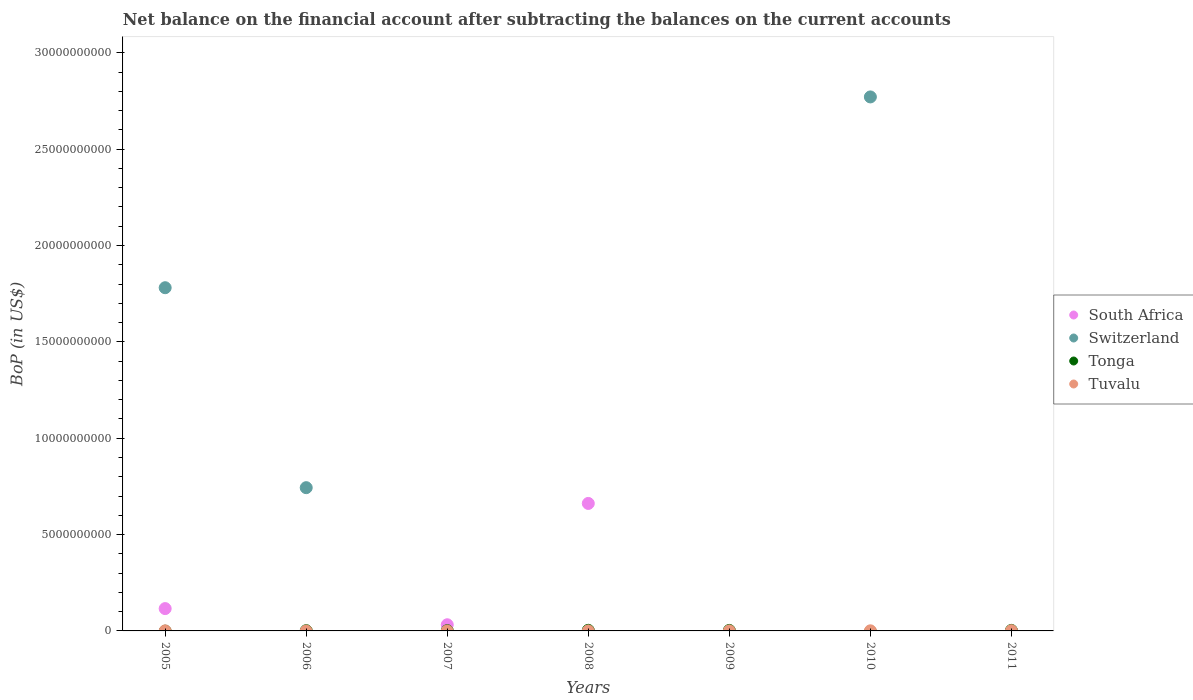How many different coloured dotlines are there?
Give a very brief answer. 4. Is the number of dotlines equal to the number of legend labels?
Provide a short and direct response. No. What is the Balance of Payments in Tonga in 2007?
Make the answer very short. 1.37e+07. Across all years, what is the maximum Balance of Payments in Tuvalu?
Your response must be concise. 1.17e+07. Across all years, what is the minimum Balance of Payments in Tuvalu?
Keep it short and to the point. 0. What is the total Balance of Payments in Tuvalu in the graph?
Provide a short and direct response. 2.20e+07. What is the difference between the Balance of Payments in Tonga in 2008 and that in 2009?
Offer a terse response. 5.54e+06. What is the average Balance of Payments in Switzerland per year?
Your answer should be compact. 7.56e+09. In the year 2008, what is the difference between the Balance of Payments in Tuvalu and Balance of Payments in South Africa?
Your answer should be compact. -6.61e+09. In how many years, is the Balance of Payments in Tuvalu greater than 19000000000 US$?
Your answer should be very brief. 0. Is the Balance of Payments in South Africa in 2005 less than that in 2008?
Your answer should be compact. Yes. What is the difference between the highest and the second highest Balance of Payments in South Africa?
Provide a short and direct response. 5.46e+09. What is the difference between the highest and the lowest Balance of Payments in Tonga?
Your answer should be compact. 3.14e+07. Is the sum of the Balance of Payments in Tuvalu in 2008 and 2011 greater than the maximum Balance of Payments in Tonga across all years?
Your response must be concise. No. Is it the case that in every year, the sum of the Balance of Payments in Tuvalu and Balance of Payments in Switzerland  is greater than the Balance of Payments in Tonga?
Offer a terse response. No. Does the Balance of Payments in Switzerland monotonically increase over the years?
Offer a very short reply. No. What is the difference between two consecutive major ticks on the Y-axis?
Provide a succinct answer. 5.00e+09. Does the graph contain any zero values?
Provide a short and direct response. Yes. How are the legend labels stacked?
Make the answer very short. Vertical. What is the title of the graph?
Offer a terse response. Net balance on the financial account after subtracting the balances on the current accounts. What is the label or title of the Y-axis?
Your response must be concise. BoP (in US$). What is the BoP (in US$) in South Africa in 2005?
Keep it short and to the point. 1.16e+09. What is the BoP (in US$) of Switzerland in 2005?
Provide a short and direct response. 1.78e+1. What is the BoP (in US$) in Tuvalu in 2005?
Offer a terse response. 2.27e+06. What is the BoP (in US$) of Switzerland in 2006?
Provide a short and direct response. 7.43e+09. What is the BoP (in US$) in Tonga in 2006?
Your answer should be very brief. 1.19e+07. What is the BoP (in US$) of Tuvalu in 2006?
Make the answer very short. 0. What is the BoP (in US$) in South Africa in 2007?
Provide a succinct answer. 3.20e+08. What is the BoP (in US$) of Tonga in 2007?
Give a very brief answer. 1.37e+07. What is the BoP (in US$) of Tuvalu in 2007?
Offer a very short reply. 0. What is the BoP (in US$) of South Africa in 2008?
Offer a terse response. 6.62e+09. What is the BoP (in US$) in Switzerland in 2008?
Offer a terse response. 0. What is the BoP (in US$) in Tonga in 2008?
Provide a short and direct response. 3.14e+07. What is the BoP (in US$) of Tuvalu in 2008?
Keep it short and to the point. 6.64e+05. What is the BoP (in US$) in South Africa in 2009?
Offer a terse response. 0. What is the BoP (in US$) in Tonga in 2009?
Give a very brief answer. 2.58e+07. What is the BoP (in US$) in Tuvalu in 2009?
Ensure brevity in your answer.  1.93e+06. What is the BoP (in US$) of South Africa in 2010?
Provide a succinct answer. 0. What is the BoP (in US$) in Switzerland in 2010?
Provide a succinct answer. 2.77e+1. What is the BoP (in US$) of Tonga in 2010?
Offer a very short reply. 0. What is the BoP (in US$) in Tuvalu in 2010?
Your response must be concise. 5.42e+06. What is the BoP (in US$) of Switzerland in 2011?
Your answer should be very brief. 0. What is the BoP (in US$) in Tonga in 2011?
Your answer should be compact. 2.61e+07. What is the BoP (in US$) in Tuvalu in 2011?
Your answer should be very brief. 1.17e+07. Across all years, what is the maximum BoP (in US$) of South Africa?
Offer a very short reply. 6.62e+09. Across all years, what is the maximum BoP (in US$) in Switzerland?
Offer a very short reply. 2.77e+1. Across all years, what is the maximum BoP (in US$) in Tonga?
Your answer should be very brief. 3.14e+07. Across all years, what is the maximum BoP (in US$) in Tuvalu?
Offer a very short reply. 1.17e+07. Across all years, what is the minimum BoP (in US$) of South Africa?
Provide a succinct answer. 0. Across all years, what is the minimum BoP (in US$) in Tonga?
Make the answer very short. 0. Across all years, what is the minimum BoP (in US$) in Tuvalu?
Ensure brevity in your answer.  0. What is the total BoP (in US$) of South Africa in the graph?
Your answer should be very brief. 8.09e+09. What is the total BoP (in US$) of Switzerland in the graph?
Your response must be concise. 5.29e+1. What is the total BoP (in US$) of Tonga in the graph?
Provide a short and direct response. 1.09e+08. What is the total BoP (in US$) in Tuvalu in the graph?
Your answer should be very brief. 2.20e+07. What is the difference between the BoP (in US$) in Switzerland in 2005 and that in 2006?
Give a very brief answer. 1.04e+1. What is the difference between the BoP (in US$) of South Africa in 2005 and that in 2007?
Offer a terse response. 8.39e+08. What is the difference between the BoP (in US$) of South Africa in 2005 and that in 2008?
Your answer should be compact. -5.46e+09. What is the difference between the BoP (in US$) in Tuvalu in 2005 and that in 2008?
Offer a very short reply. 1.61e+06. What is the difference between the BoP (in US$) of Tuvalu in 2005 and that in 2009?
Make the answer very short. 3.41e+05. What is the difference between the BoP (in US$) in Switzerland in 2005 and that in 2010?
Give a very brief answer. -9.90e+09. What is the difference between the BoP (in US$) in Tuvalu in 2005 and that in 2010?
Your response must be concise. -3.15e+06. What is the difference between the BoP (in US$) of Tuvalu in 2005 and that in 2011?
Keep it short and to the point. -9.42e+06. What is the difference between the BoP (in US$) in Tonga in 2006 and that in 2007?
Your response must be concise. -1.85e+06. What is the difference between the BoP (in US$) in Tonga in 2006 and that in 2008?
Provide a succinct answer. -1.95e+07. What is the difference between the BoP (in US$) in Tonga in 2006 and that in 2009?
Offer a very short reply. -1.40e+07. What is the difference between the BoP (in US$) of Switzerland in 2006 and that in 2010?
Provide a succinct answer. -2.03e+1. What is the difference between the BoP (in US$) in Tonga in 2006 and that in 2011?
Keep it short and to the point. -1.42e+07. What is the difference between the BoP (in US$) of South Africa in 2007 and that in 2008?
Give a very brief answer. -6.30e+09. What is the difference between the BoP (in US$) in Tonga in 2007 and that in 2008?
Provide a succinct answer. -1.77e+07. What is the difference between the BoP (in US$) in Tonga in 2007 and that in 2009?
Offer a very short reply. -1.21e+07. What is the difference between the BoP (in US$) of Tonga in 2007 and that in 2011?
Provide a succinct answer. -1.23e+07. What is the difference between the BoP (in US$) of Tonga in 2008 and that in 2009?
Keep it short and to the point. 5.54e+06. What is the difference between the BoP (in US$) in Tuvalu in 2008 and that in 2009?
Make the answer very short. -1.27e+06. What is the difference between the BoP (in US$) in Tuvalu in 2008 and that in 2010?
Give a very brief answer. -4.76e+06. What is the difference between the BoP (in US$) of Tonga in 2008 and that in 2011?
Your answer should be compact. 5.31e+06. What is the difference between the BoP (in US$) in Tuvalu in 2008 and that in 2011?
Give a very brief answer. -1.10e+07. What is the difference between the BoP (in US$) of Tuvalu in 2009 and that in 2010?
Make the answer very short. -3.49e+06. What is the difference between the BoP (in US$) in Tonga in 2009 and that in 2011?
Provide a succinct answer. -2.33e+05. What is the difference between the BoP (in US$) in Tuvalu in 2009 and that in 2011?
Your answer should be compact. -9.76e+06. What is the difference between the BoP (in US$) of Tuvalu in 2010 and that in 2011?
Ensure brevity in your answer.  -6.27e+06. What is the difference between the BoP (in US$) in South Africa in 2005 and the BoP (in US$) in Switzerland in 2006?
Provide a short and direct response. -6.27e+09. What is the difference between the BoP (in US$) of South Africa in 2005 and the BoP (in US$) of Tonga in 2006?
Provide a succinct answer. 1.15e+09. What is the difference between the BoP (in US$) of Switzerland in 2005 and the BoP (in US$) of Tonga in 2006?
Provide a short and direct response. 1.78e+1. What is the difference between the BoP (in US$) in South Africa in 2005 and the BoP (in US$) in Tonga in 2007?
Your answer should be compact. 1.14e+09. What is the difference between the BoP (in US$) of Switzerland in 2005 and the BoP (in US$) of Tonga in 2007?
Make the answer very short. 1.78e+1. What is the difference between the BoP (in US$) of South Africa in 2005 and the BoP (in US$) of Tonga in 2008?
Make the answer very short. 1.13e+09. What is the difference between the BoP (in US$) in South Africa in 2005 and the BoP (in US$) in Tuvalu in 2008?
Give a very brief answer. 1.16e+09. What is the difference between the BoP (in US$) of Switzerland in 2005 and the BoP (in US$) of Tonga in 2008?
Make the answer very short. 1.78e+1. What is the difference between the BoP (in US$) in Switzerland in 2005 and the BoP (in US$) in Tuvalu in 2008?
Make the answer very short. 1.78e+1. What is the difference between the BoP (in US$) in South Africa in 2005 and the BoP (in US$) in Tonga in 2009?
Your answer should be very brief. 1.13e+09. What is the difference between the BoP (in US$) of South Africa in 2005 and the BoP (in US$) of Tuvalu in 2009?
Your response must be concise. 1.16e+09. What is the difference between the BoP (in US$) in Switzerland in 2005 and the BoP (in US$) in Tonga in 2009?
Ensure brevity in your answer.  1.78e+1. What is the difference between the BoP (in US$) of Switzerland in 2005 and the BoP (in US$) of Tuvalu in 2009?
Ensure brevity in your answer.  1.78e+1. What is the difference between the BoP (in US$) in South Africa in 2005 and the BoP (in US$) in Switzerland in 2010?
Provide a succinct answer. -2.65e+1. What is the difference between the BoP (in US$) of South Africa in 2005 and the BoP (in US$) of Tuvalu in 2010?
Give a very brief answer. 1.15e+09. What is the difference between the BoP (in US$) of Switzerland in 2005 and the BoP (in US$) of Tuvalu in 2010?
Offer a very short reply. 1.78e+1. What is the difference between the BoP (in US$) in South Africa in 2005 and the BoP (in US$) in Tonga in 2011?
Give a very brief answer. 1.13e+09. What is the difference between the BoP (in US$) of South Africa in 2005 and the BoP (in US$) of Tuvalu in 2011?
Keep it short and to the point. 1.15e+09. What is the difference between the BoP (in US$) of Switzerland in 2005 and the BoP (in US$) of Tonga in 2011?
Make the answer very short. 1.78e+1. What is the difference between the BoP (in US$) in Switzerland in 2005 and the BoP (in US$) in Tuvalu in 2011?
Your answer should be compact. 1.78e+1. What is the difference between the BoP (in US$) of Switzerland in 2006 and the BoP (in US$) of Tonga in 2007?
Give a very brief answer. 7.42e+09. What is the difference between the BoP (in US$) of Switzerland in 2006 and the BoP (in US$) of Tonga in 2008?
Offer a very short reply. 7.40e+09. What is the difference between the BoP (in US$) in Switzerland in 2006 and the BoP (in US$) in Tuvalu in 2008?
Keep it short and to the point. 7.43e+09. What is the difference between the BoP (in US$) in Tonga in 2006 and the BoP (in US$) in Tuvalu in 2008?
Offer a very short reply. 1.12e+07. What is the difference between the BoP (in US$) of Switzerland in 2006 and the BoP (in US$) of Tonga in 2009?
Your answer should be compact. 7.41e+09. What is the difference between the BoP (in US$) in Switzerland in 2006 and the BoP (in US$) in Tuvalu in 2009?
Offer a very short reply. 7.43e+09. What is the difference between the BoP (in US$) in Tonga in 2006 and the BoP (in US$) in Tuvalu in 2009?
Offer a very short reply. 9.95e+06. What is the difference between the BoP (in US$) in Switzerland in 2006 and the BoP (in US$) in Tuvalu in 2010?
Offer a terse response. 7.43e+09. What is the difference between the BoP (in US$) in Tonga in 2006 and the BoP (in US$) in Tuvalu in 2010?
Your answer should be very brief. 6.46e+06. What is the difference between the BoP (in US$) of Switzerland in 2006 and the BoP (in US$) of Tonga in 2011?
Offer a terse response. 7.41e+09. What is the difference between the BoP (in US$) in Switzerland in 2006 and the BoP (in US$) in Tuvalu in 2011?
Your answer should be compact. 7.42e+09. What is the difference between the BoP (in US$) of Tonga in 2006 and the BoP (in US$) of Tuvalu in 2011?
Offer a very short reply. 1.88e+05. What is the difference between the BoP (in US$) in South Africa in 2007 and the BoP (in US$) in Tonga in 2008?
Provide a succinct answer. 2.89e+08. What is the difference between the BoP (in US$) of South Africa in 2007 and the BoP (in US$) of Tuvalu in 2008?
Keep it short and to the point. 3.19e+08. What is the difference between the BoP (in US$) of Tonga in 2007 and the BoP (in US$) of Tuvalu in 2008?
Give a very brief answer. 1.31e+07. What is the difference between the BoP (in US$) in South Africa in 2007 and the BoP (in US$) in Tonga in 2009?
Make the answer very short. 2.94e+08. What is the difference between the BoP (in US$) of South Africa in 2007 and the BoP (in US$) of Tuvalu in 2009?
Provide a succinct answer. 3.18e+08. What is the difference between the BoP (in US$) in Tonga in 2007 and the BoP (in US$) in Tuvalu in 2009?
Provide a succinct answer. 1.18e+07. What is the difference between the BoP (in US$) of South Africa in 2007 and the BoP (in US$) of Switzerland in 2010?
Make the answer very short. -2.74e+1. What is the difference between the BoP (in US$) of South Africa in 2007 and the BoP (in US$) of Tuvalu in 2010?
Ensure brevity in your answer.  3.15e+08. What is the difference between the BoP (in US$) in Tonga in 2007 and the BoP (in US$) in Tuvalu in 2010?
Your response must be concise. 8.31e+06. What is the difference between the BoP (in US$) of South Africa in 2007 and the BoP (in US$) of Tonga in 2011?
Keep it short and to the point. 2.94e+08. What is the difference between the BoP (in US$) in South Africa in 2007 and the BoP (in US$) in Tuvalu in 2011?
Your response must be concise. 3.08e+08. What is the difference between the BoP (in US$) of Tonga in 2007 and the BoP (in US$) of Tuvalu in 2011?
Keep it short and to the point. 2.04e+06. What is the difference between the BoP (in US$) in South Africa in 2008 and the BoP (in US$) in Tonga in 2009?
Make the answer very short. 6.59e+09. What is the difference between the BoP (in US$) of South Africa in 2008 and the BoP (in US$) of Tuvalu in 2009?
Provide a short and direct response. 6.61e+09. What is the difference between the BoP (in US$) in Tonga in 2008 and the BoP (in US$) in Tuvalu in 2009?
Keep it short and to the point. 2.95e+07. What is the difference between the BoP (in US$) of South Africa in 2008 and the BoP (in US$) of Switzerland in 2010?
Ensure brevity in your answer.  -2.11e+1. What is the difference between the BoP (in US$) in South Africa in 2008 and the BoP (in US$) in Tuvalu in 2010?
Keep it short and to the point. 6.61e+09. What is the difference between the BoP (in US$) of Tonga in 2008 and the BoP (in US$) of Tuvalu in 2010?
Your response must be concise. 2.60e+07. What is the difference between the BoP (in US$) in South Africa in 2008 and the BoP (in US$) in Tonga in 2011?
Provide a short and direct response. 6.59e+09. What is the difference between the BoP (in US$) of South Africa in 2008 and the BoP (in US$) of Tuvalu in 2011?
Your answer should be very brief. 6.60e+09. What is the difference between the BoP (in US$) of Tonga in 2008 and the BoP (in US$) of Tuvalu in 2011?
Provide a short and direct response. 1.97e+07. What is the difference between the BoP (in US$) of Tonga in 2009 and the BoP (in US$) of Tuvalu in 2010?
Give a very brief answer. 2.04e+07. What is the difference between the BoP (in US$) in Tonga in 2009 and the BoP (in US$) in Tuvalu in 2011?
Make the answer very short. 1.41e+07. What is the difference between the BoP (in US$) in Switzerland in 2010 and the BoP (in US$) in Tonga in 2011?
Give a very brief answer. 2.77e+1. What is the difference between the BoP (in US$) in Switzerland in 2010 and the BoP (in US$) in Tuvalu in 2011?
Your answer should be very brief. 2.77e+1. What is the average BoP (in US$) of South Africa per year?
Provide a short and direct response. 1.16e+09. What is the average BoP (in US$) in Switzerland per year?
Make the answer very short. 7.56e+09. What is the average BoP (in US$) of Tonga per year?
Offer a terse response. 1.56e+07. What is the average BoP (in US$) in Tuvalu per year?
Provide a short and direct response. 3.14e+06. In the year 2005, what is the difference between the BoP (in US$) in South Africa and BoP (in US$) in Switzerland?
Provide a succinct answer. -1.66e+1. In the year 2005, what is the difference between the BoP (in US$) of South Africa and BoP (in US$) of Tuvalu?
Offer a terse response. 1.16e+09. In the year 2005, what is the difference between the BoP (in US$) of Switzerland and BoP (in US$) of Tuvalu?
Your answer should be very brief. 1.78e+1. In the year 2006, what is the difference between the BoP (in US$) of Switzerland and BoP (in US$) of Tonga?
Your answer should be very brief. 7.42e+09. In the year 2007, what is the difference between the BoP (in US$) in South Africa and BoP (in US$) in Tonga?
Offer a very short reply. 3.06e+08. In the year 2008, what is the difference between the BoP (in US$) in South Africa and BoP (in US$) in Tonga?
Provide a succinct answer. 6.58e+09. In the year 2008, what is the difference between the BoP (in US$) of South Africa and BoP (in US$) of Tuvalu?
Give a very brief answer. 6.61e+09. In the year 2008, what is the difference between the BoP (in US$) of Tonga and BoP (in US$) of Tuvalu?
Your response must be concise. 3.07e+07. In the year 2009, what is the difference between the BoP (in US$) in Tonga and BoP (in US$) in Tuvalu?
Your answer should be compact. 2.39e+07. In the year 2010, what is the difference between the BoP (in US$) of Switzerland and BoP (in US$) of Tuvalu?
Ensure brevity in your answer.  2.77e+1. In the year 2011, what is the difference between the BoP (in US$) of Tonga and BoP (in US$) of Tuvalu?
Your answer should be compact. 1.44e+07. What is the ratio of the BoP (in US$) of Switzerland in 2005 to that in 2006?
Provide a succinct answer. 2.4. What is the ratio of the BoP (in US$) of South Africa in 2005 to that in 2007?
Your response must be concise. 3.62. What is the ratio of the BoP (in US$) of South Africa in 2005 to that in 2008?
Provide a short and direct response. 0.18. What is the ratio of the BoP (in US$) of Tuvalu in 2005 to that in 2008?
Offer a very short reply. 3.43. What is the ratio of the BoP (in US$) in Tuvalu in 2005 to that in 2009?
Ensure brevity in your answer.  1.18. What is the ratio of the BoP (in US$) in Switzerland in 2005 to that in 2010?
Keep it short and to the point. 0.64. What is the ratio of the BoP (in US$) in Tuvalu in 2005 to that in 2010?
Ensure brevity in your answer.  0.42. What is the ratio of the BoP (in US$) in Tuvalu in 2005 to that in 2011?
Offer a terse response. 0.19. What is the ratio of the BoP (in US$) of Tonga in 2006 to that in 2007?
Your answer should be very brief. 0.87. What is the ratio of the BoP (in US$) in Tonga in 2006 to that in 2008?
Offer a terse response. 0.38. What is the ratio of the BoP (in US$) in Tonga in 2006 to that in 2009?
Your answer should be compact. 0.46. What is the ratio of the BoP (in US$) in Switzerland in 2006 to that in 2010?
Ensure brevity in your answer.  0.27. What is the ratio of the BoP (in US$) in Tonga in 2006 to that in 2011?
Keep it short and to the point. 0.46. What is the ratio of the BoP (in US$) of South Africa in 2007 to that in 2008?
Offer a terse response. 0.05. What is the ratio of the BoP (in US$) of Tonga in 2007 to that in 2008?
Offer a terse response. 0.44. What is the ratio of the BoP (in US$) of Tonga in 2007 to that in 2009?
Offer a very short reply. 0.53. What is the ratio of the BoP (in US$) of Tonga in 2007 to that in 2011?
Provide a succinct answer. 0.53. What is the ratio of the BoP (in US$) of Tonga in 2008 to that in 2009?
Your answer should be compact. 1.21. What is the ratio of the BoP (in US$) in Tuvalu in 2008 to that in 2009?
Keep it short and to the point. 0.34. What is the ratio of the BoP (in US$) in Tuvalu in 2008 to that in 2010?
Provide a short and direct response. 0.12. What is the ratio of the BoP (in US$) of Tonga in 2008 to that in 2011?
Keep it short and to the point. 1.2. What is the ratio of the BoP (in US$) of Tuvalu in 2008 to that in 2011?
Offer a terse response. 0.06. What is the ratio of the BoP (in US$) of Tuvalu in 2009 to that in 2010?
Provide a short and direct response. 0.36. What is the ratio of the BoP (in US$) of Tonga in 2009 to that in 2011?
Offer a very short reply. 0.99. What is the ratio of the BoP (in US$) of Tuvalu in 2009 to that in 2011?
Give a very brief answer. 0.17. What is the ratio of the BoP (in US$) of Tuvalu in 2010 to that in 2011?
Offer a terse response. 0.46. What is the difference between the highest and the second highest BoP (in US$) of South Africa?
Keep it short and to the point. 5.46e+09. What is the difference between the highest and the second highest BoP (in US$) in Switzerland?
Make the answer very short. 9.90e+09. What is the difference between the highest and the second highest BoP (in US$) of Tonga?
Offer a very short reply. 5.31e+06. What is the difference between the highest and the second highest BoP (in US$) in Tuvalu?
Keep it short and to the point. 6.27e+06. What is the difference between the highest and the lowest BoP (in US$) of South Africa?
Offer a terse response. 6.62e+09. What is the difference between the highest and the lowest BoP (in US$) of Switzerland?
Provide a short and direct response. 2.77e+1. What is the difference between the highest and the lowest BoP (in US$) in Tonga?
Offer a very short reply. 3.14e+07. What is the difference between the highest and the lowest BoP (in US$) in Tuvalu?
Make the answer very short. 1.17e+07. 